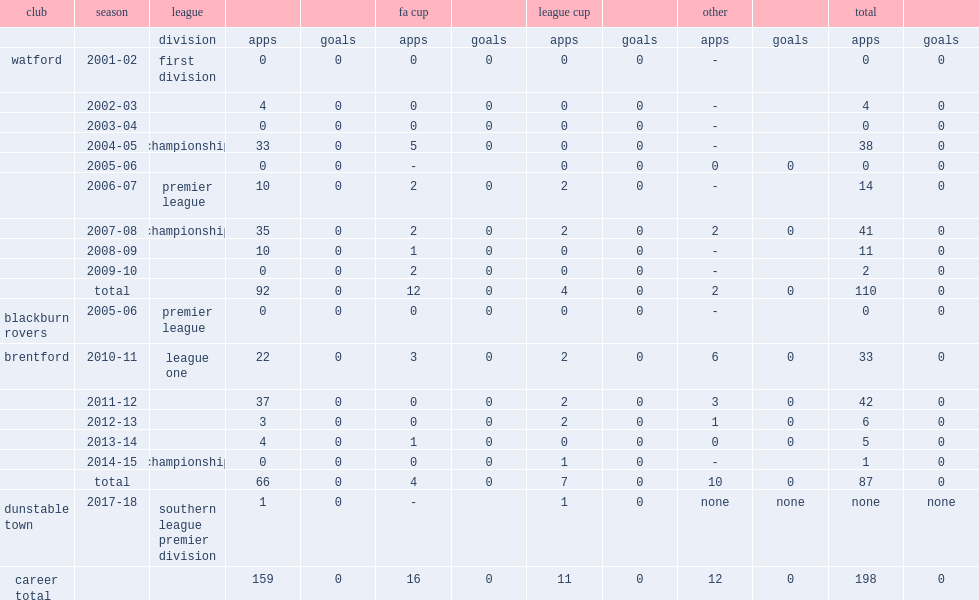What was the number of appearances made by lee during the 2004-05 championship season? 38.0. 